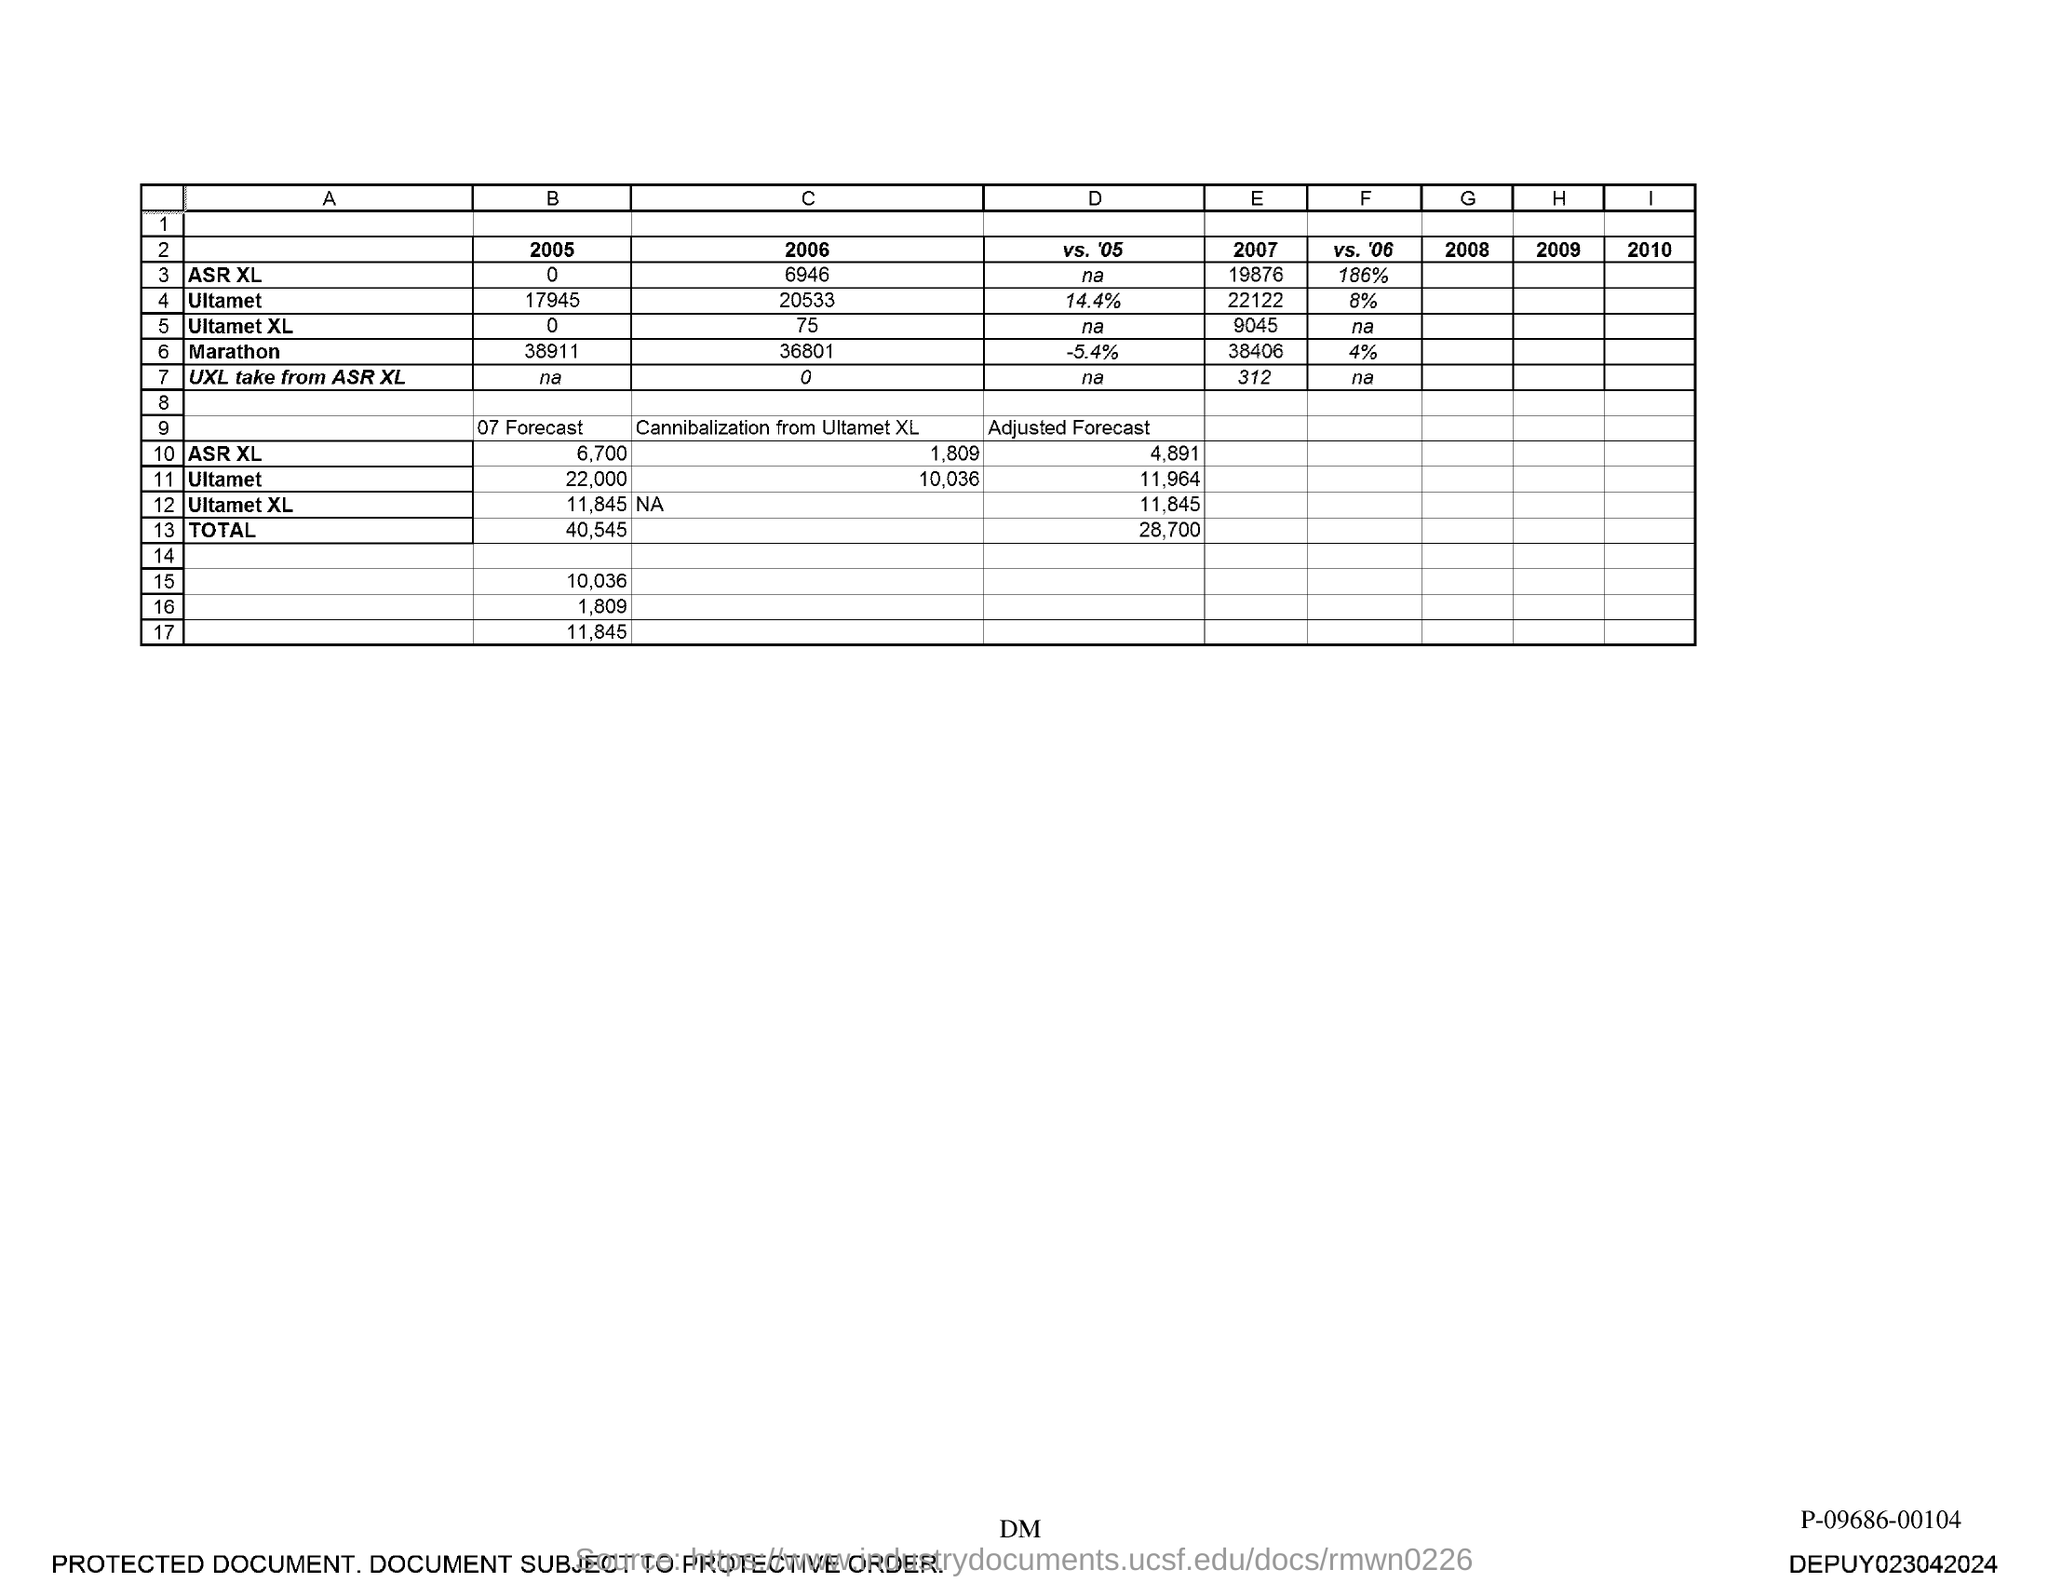What is the adjusted forecast for ASR XL?
Make the answer very short. 4,891. 